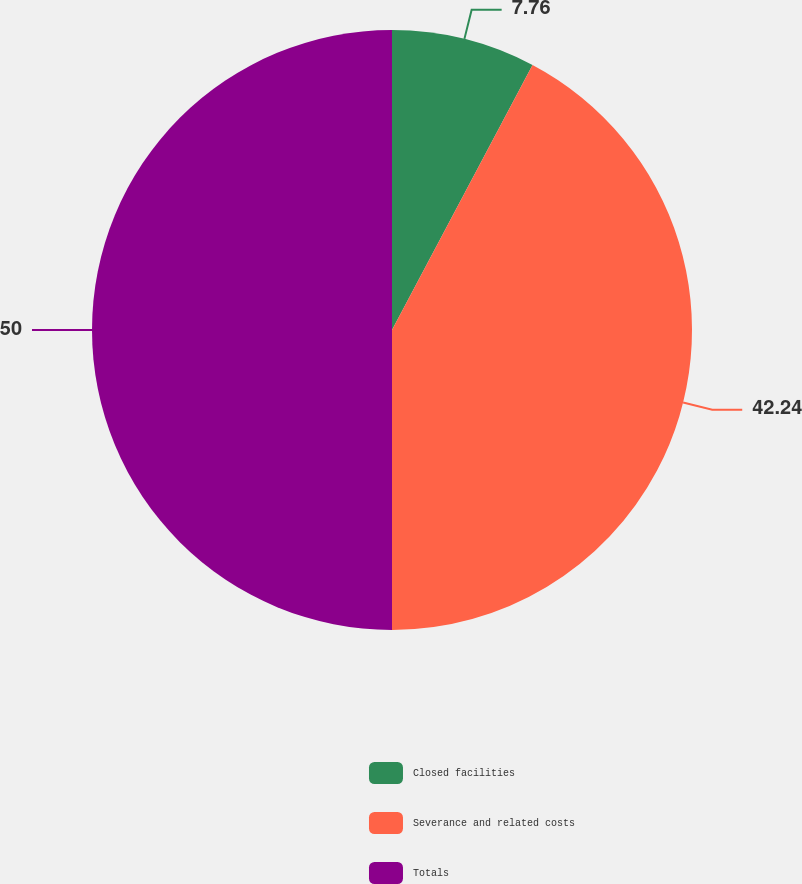<chart> <loc_0><loc_0><loc_500><loc_500><pie_chart><fcel>Closed facilities<fcel>Severance and related costs<fcel>Totals<nl><fcel>7.76%<fcel>42.24%<fcel>50.0%<nl></chart> 